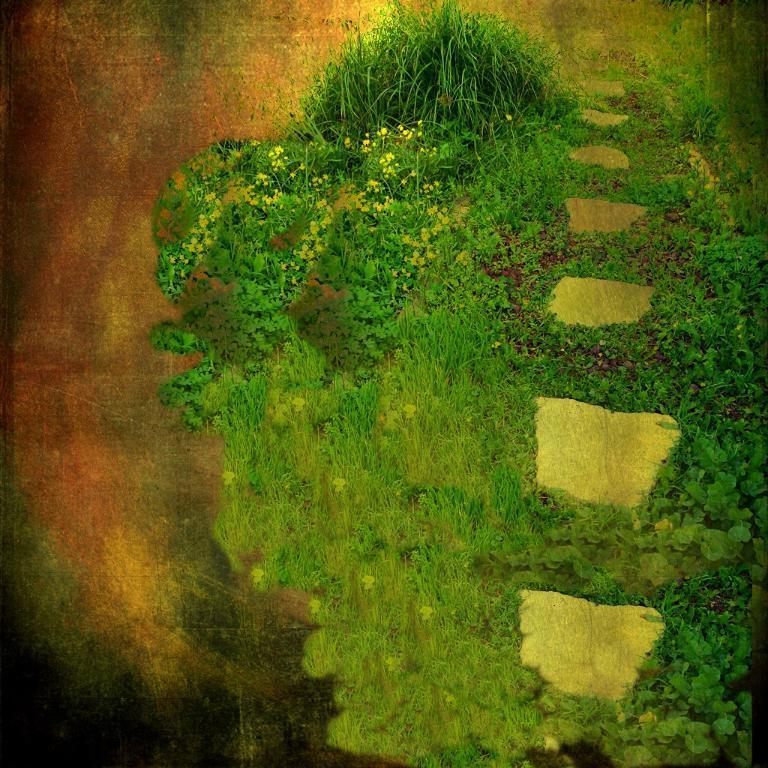In one or two sentences, can you explain what this image depicts? This is an edited picture. I can see grass and plants. 